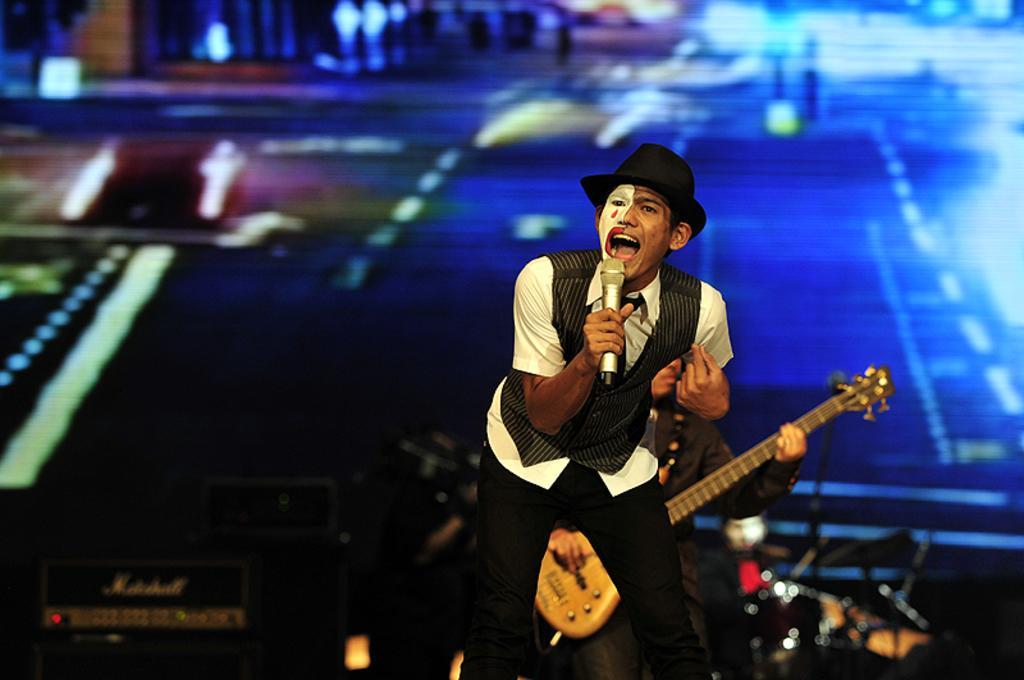Please provide a concise description of this image. This image is clicked in a concert. In the front, there is a man wearing hat is singing. In the background, there is a person playing guitar. To the left, there is a speaker. In the background, there is a screen. 